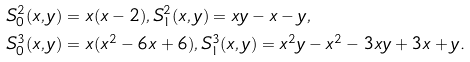Convert formula to latex. <formula><loc_0><loc_0><loc_500><loc_500>& S _ { 0 } ^ { 2 } ( x , y ) = x ( x - 2 ) , S _ { 1 } ^ { 2 } ( x , y ) = x y - x - y , \\ & S _ { 0 } ^ { 3 } ( x , y ) = x ( x ^ { 2 } - 6 x + 6 ) , S _ { 1 } ^ { 3 } ( x , y ) = x ^ { 2 } y - x ^ { 2 } - 3 x y + 3 x + y .</formula> 